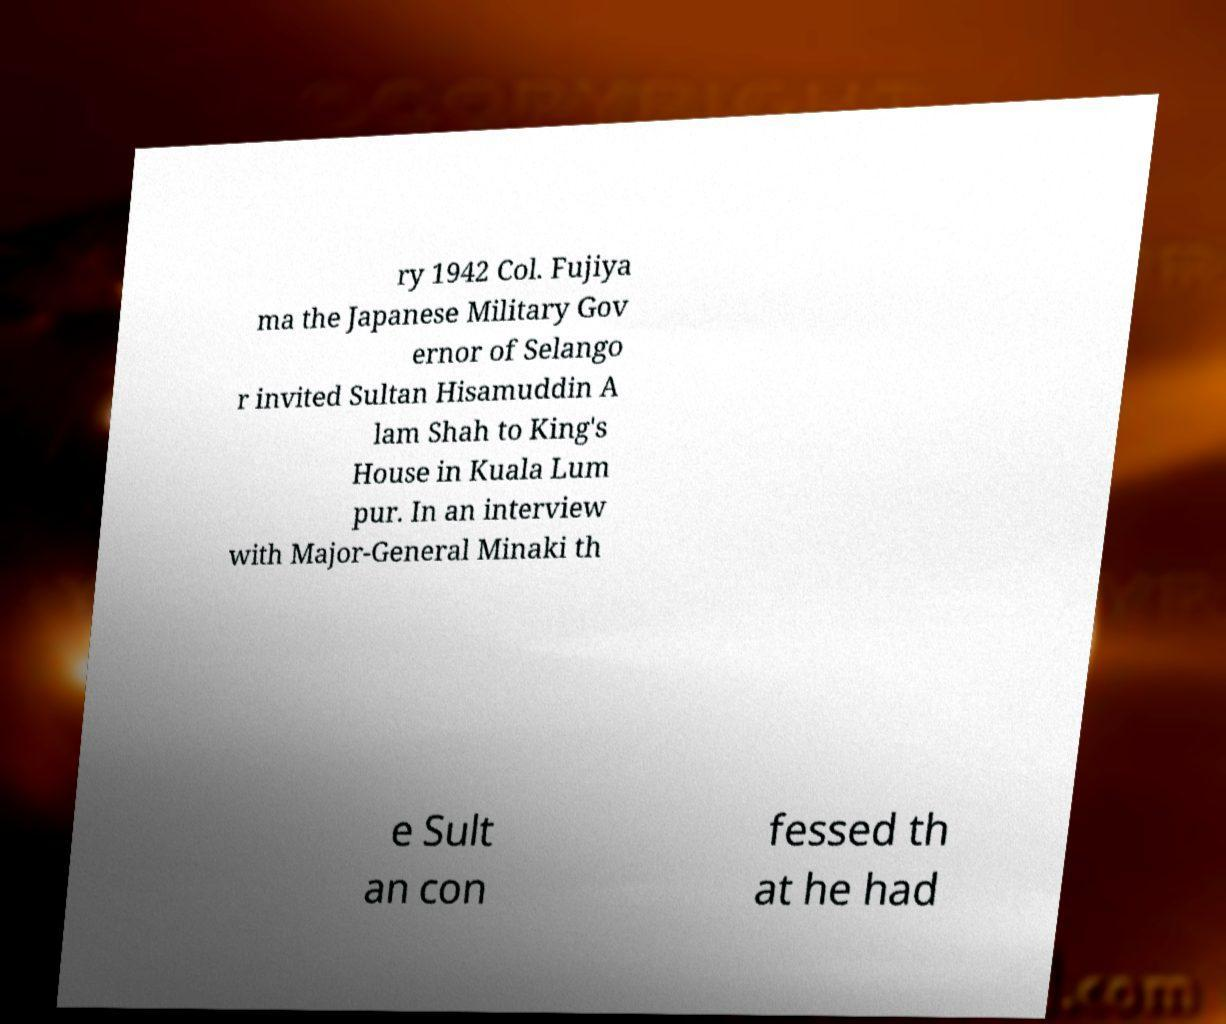Could you assist in decoding the text presented in this image and type it out clearly? ry 1942 Col. Fujiya ma the Japanese Military Gov ernor of Selango r invited Sultan Hisamuddin A lam Shah to King's House in Kuala Lum pur. In an interview with Major-General Minaki th e Sult an con fessed th at he had 